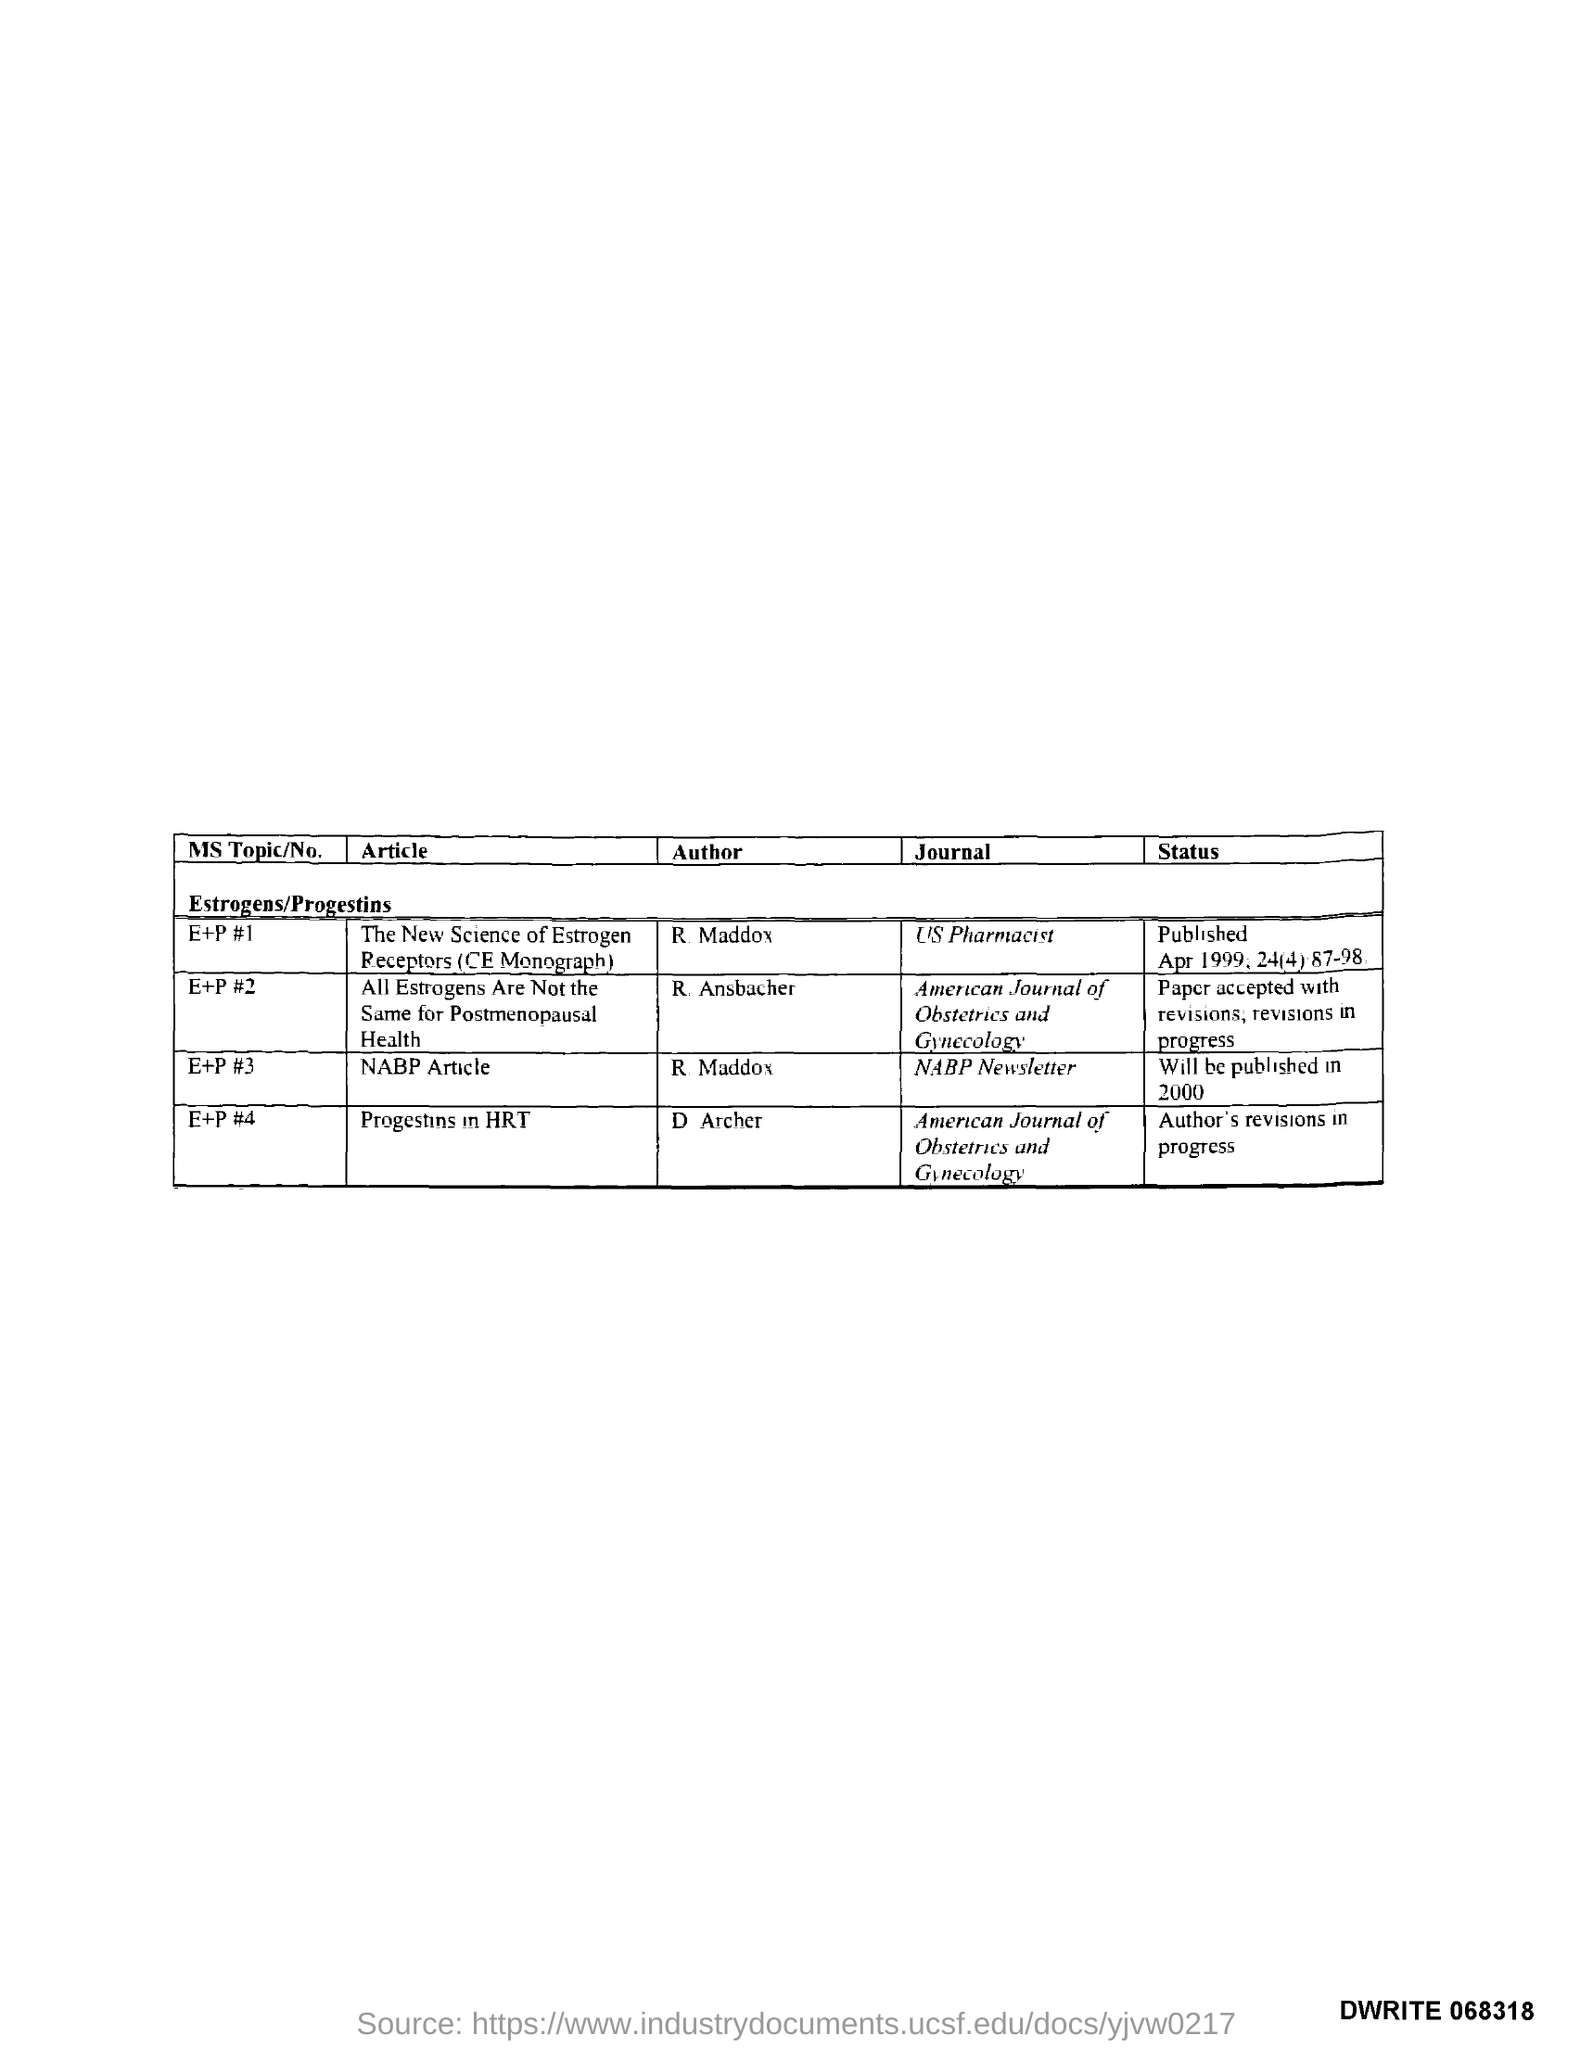Specify some key components in this picture. The article titled "The New Science of Estrogen Receptors (CE Monograph)" was published in the journal US Pharmacist. The article titled "Progestins in HRT" was published in the American Journal of Obstetrics and Gynecology. The author of the NABP article is R Maddox. The author of the article titled "Progestins in HRT" is D. Archer. The author of the article titled "The New Science of Estrogen Receptors (CE Monograph)" is R. Maddox. 